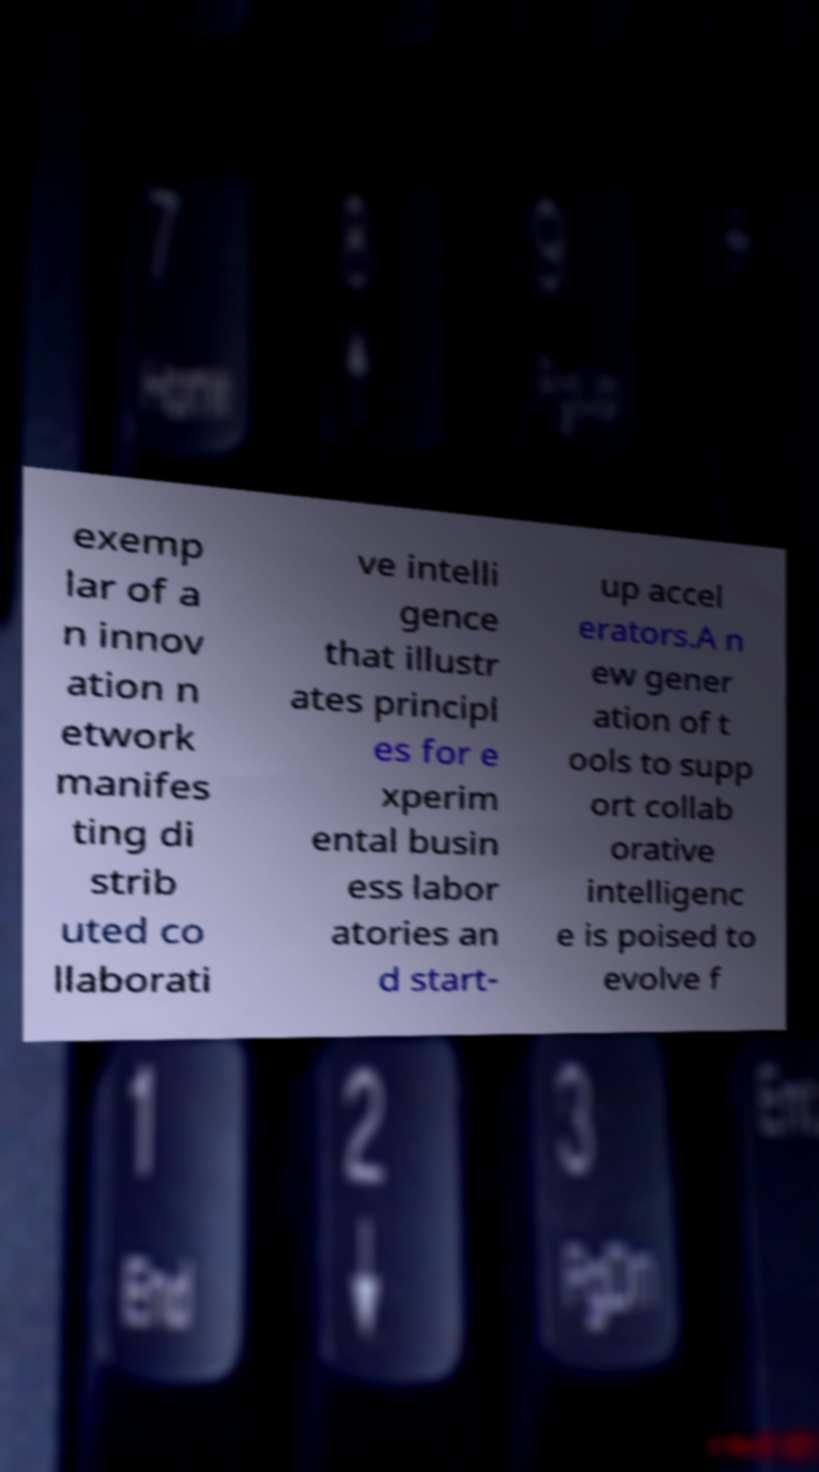What messages or text are displayed in this image? I need them in a readable, typed format. exemp lar of a n innov ation n etwork manifes ting di strib uted co llaborati ve intelli gence that illustr ates principl es for e xperim ental busin ess labor atories an d start- up accel erators.A n ew gener ation of t ools to supp ort collab orative intelligenc e is poised to evolve f 